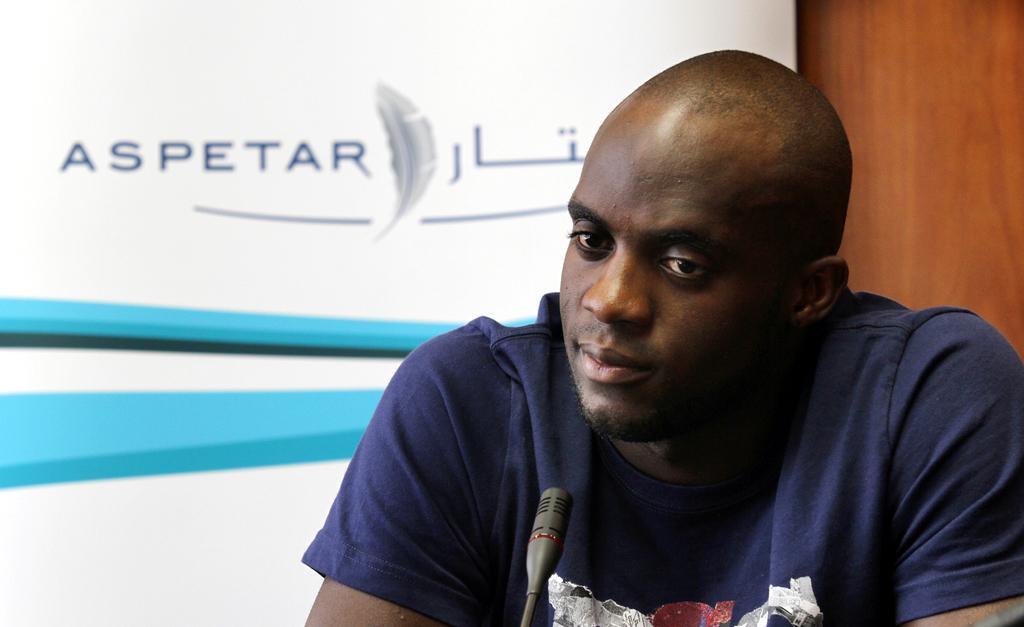Can you describe this image briefly? In the foreground of the image we can see a person wearing dark blue color T-shirt is in front of the mic. In the background, we can see the white color board on which we can see some text and blue color lines on it. Also, we can see the wooden wall here. 